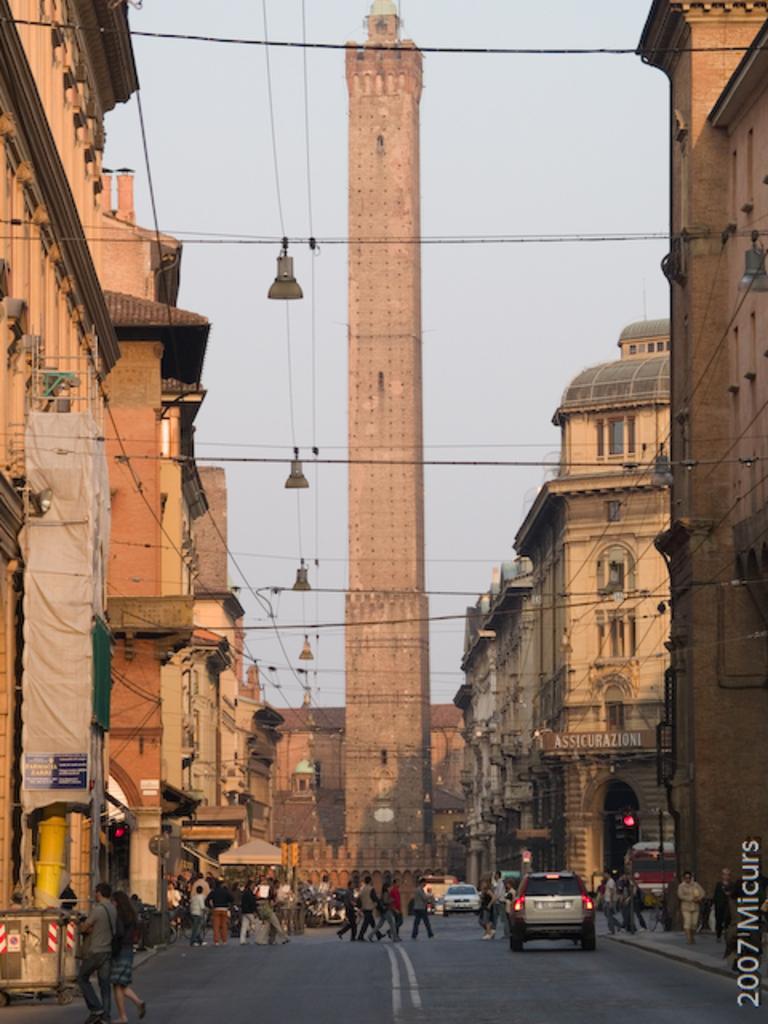How would you summarize this image in a sentence or two? In the center of the image there is a tower. To the both sides of the image there are buildings. At the bottom of the image there is road. There are people walking. There are cars. 